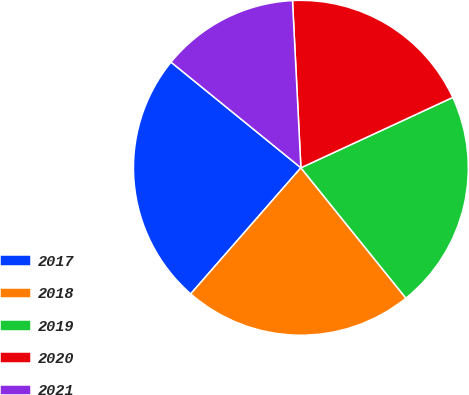Convert chart. <chart><loc_0><loc_0><loc_500><loc_500><pie_chart><fcel>2017<fcel>2018<fcel>2019<fcel>2020<fcel>2021<nl><fcel>24.44%<fcel>22.22%<fcel>21.11%<fcel>18.89%<fcel>13.33%<nl></chart> 